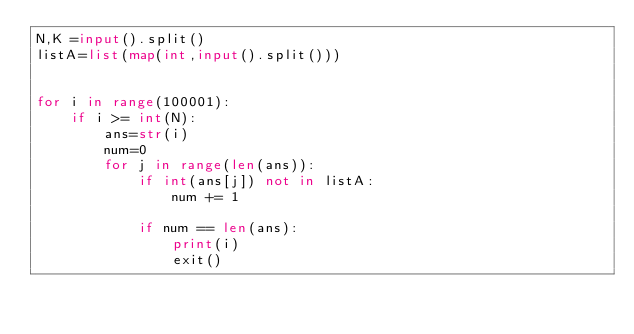Convert code to text. <code><loc_0><loc_0><loc_500><loc_500><_Python_>N,K =input().split()
listA=list(map(int,input().split()))


for i in range(100001):
    if i >= int(N):
        ans=str(i)
        num=0
        for j in range(len(ans)):
            if int(ans[j]) not in listA:
                num += 1

            if num == len(ans):
                print(i)
                exit()</code> 